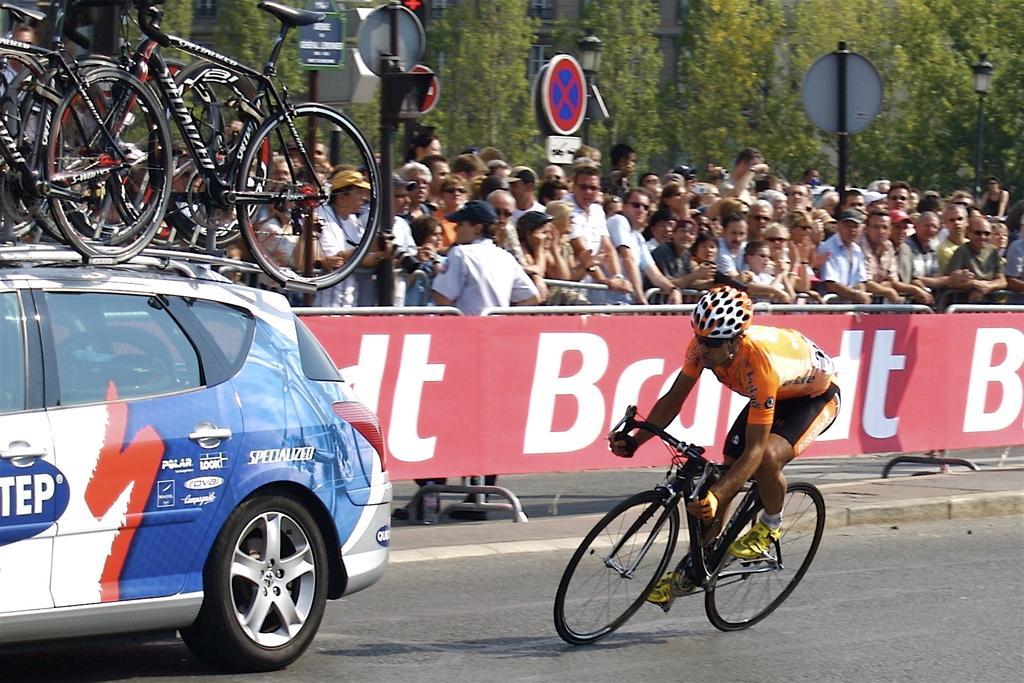In one or two sentences, can you explain what this image depicts? This is an outside view. On the right side there is a man riding a bicycle on the road towards the left side. On the left side there are few bicycles on a car. In the background there is a red color board on which I can see some text. Behind a crowd of people standing facing towards the road. In the background there are some poles and trees and also I can see a building. 